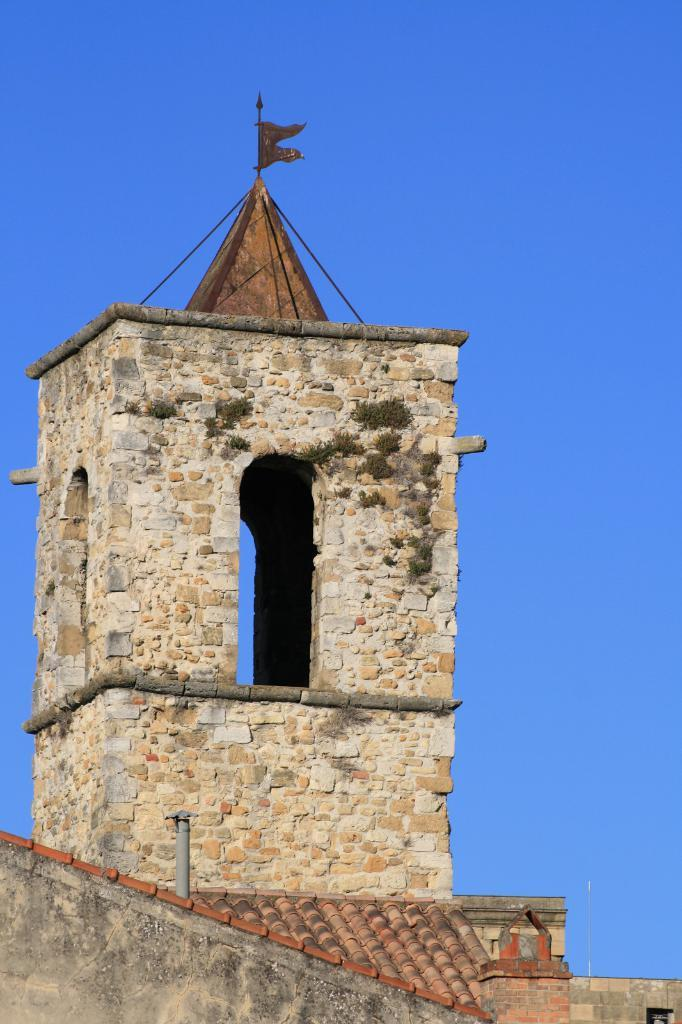What is the main structure in the image? There is a building in the image. Is there any symbol or emblem on the building? Yes, there is a flag on the building. What can be seen in the background of the image? The sky is visible in the background of the image. What type of noise can be heard coming from the building in the image? There is no indication of any noise in the image, so it cannot be determined from the picture. 